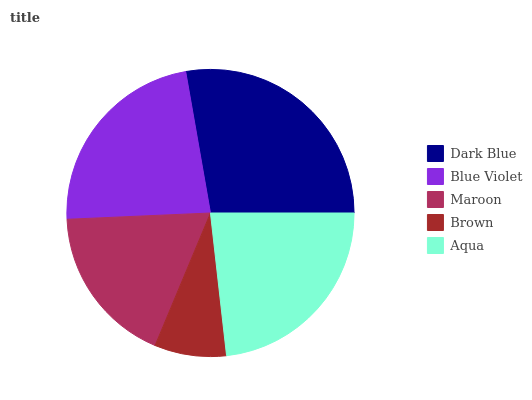Is Brown the minimum?
Answer yes or no. Yes. Is Dark Blue the maximum?
Answer yes or no. Yes. Is Blue Violet the minimum?
Answer yes or no. No. Is Blue Violet the maximum?
Answer yes or no. No. Is Dark Blue greater than Blue Violet?
Answer yes or no. Yes. Is Blue Violet less than Dark Blue?
Answer yes or no. Yes. Is Blue Violet greater than Dark Blue?
Answer yes or no. No. Is Dark Blue less than Blue Violet?
Answer yes or no. No. Is Blue Violet the high median?
Answer yes or no. Yes. Is Blue Violet the low median?
Answer yes or no. Yes. Is Maroon the high median?
Answer yes or no. No. Is Maroon the low median?
Answer yes or no. No. 